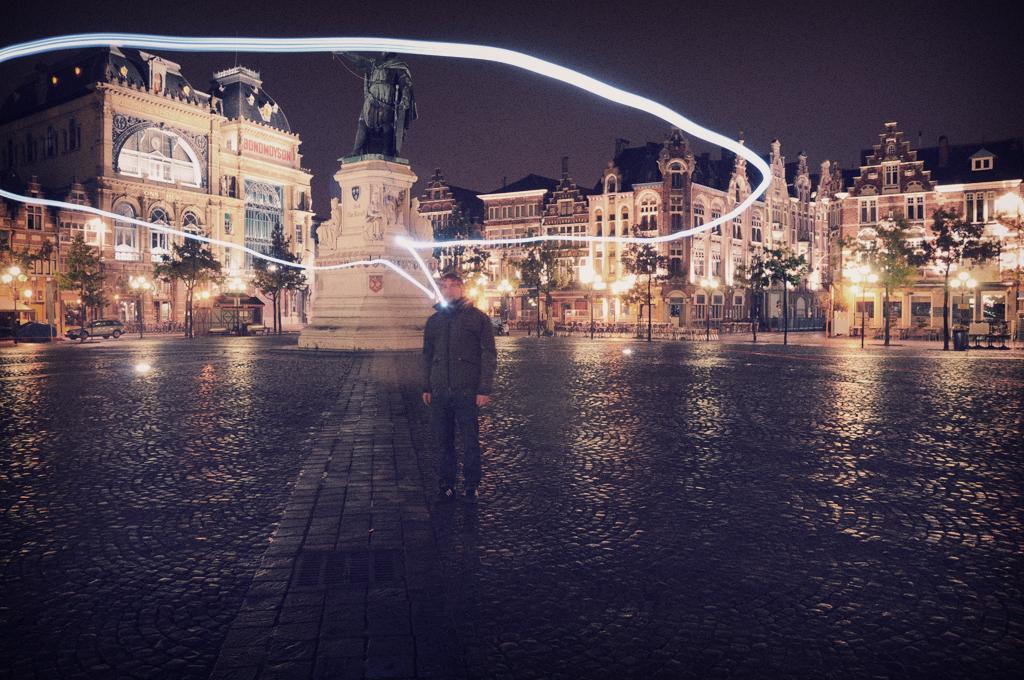Please provide a concise description of this image. In the center of the image, we can see a person standing on the road and in the background, there are buildings, poles, lights, vehicles and we can see a statue. At the top, there is sky and we can see a logo. 